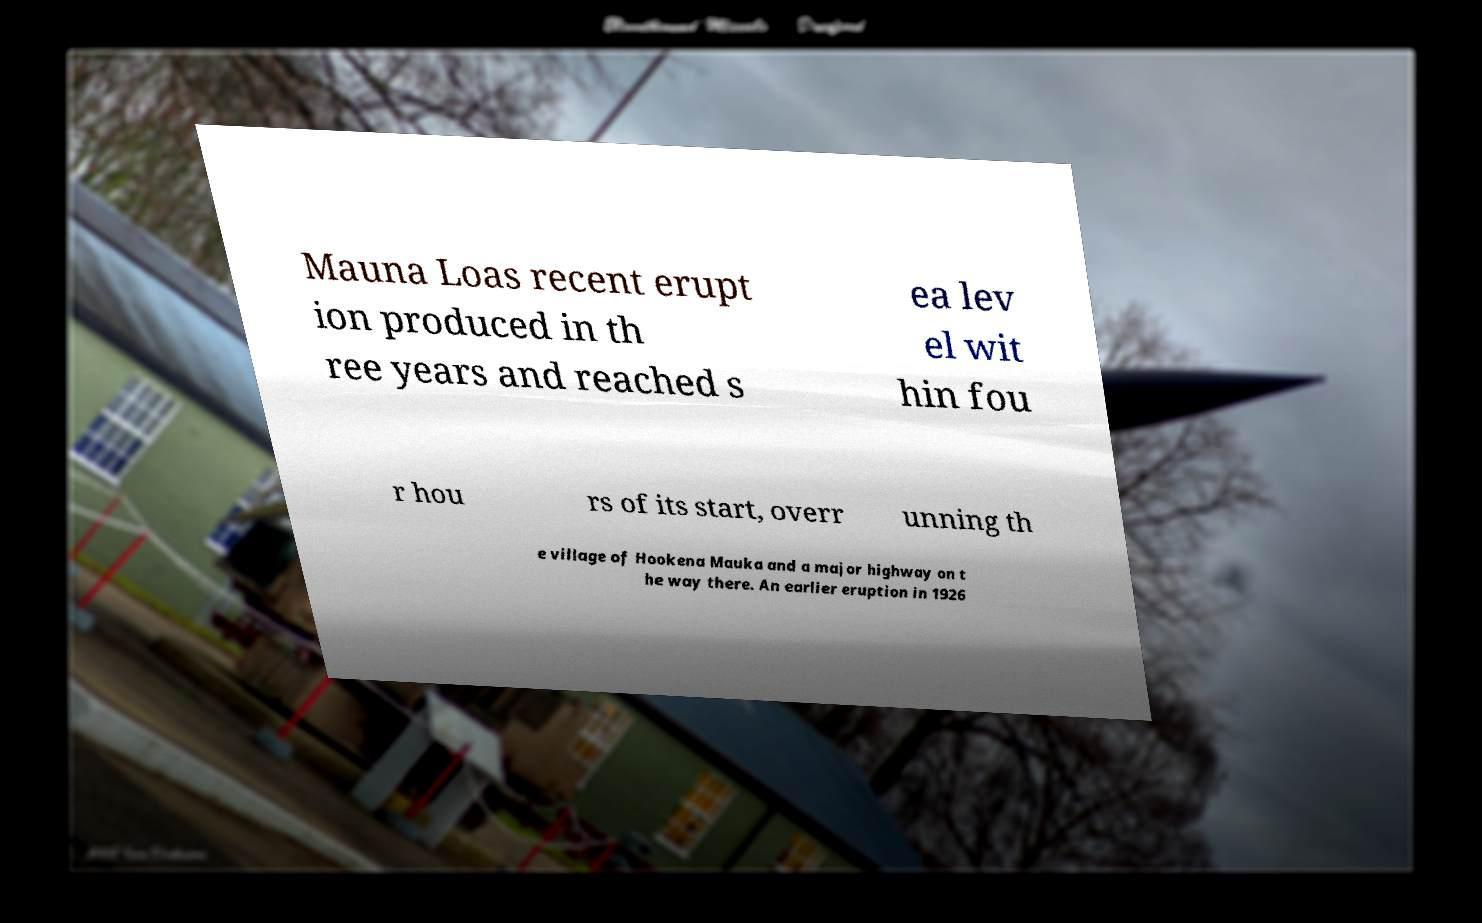There's text embedded in this image that I need extracted. Can you transcribe it verbatim? Mauna Loas recent erupt ion produced in th ree years and reached s ea lev el wit hin fou r hou rs of its start, overr unning th e village of Hookena Mauka and a major highway on t he way there. An earlier eruption in 1926 